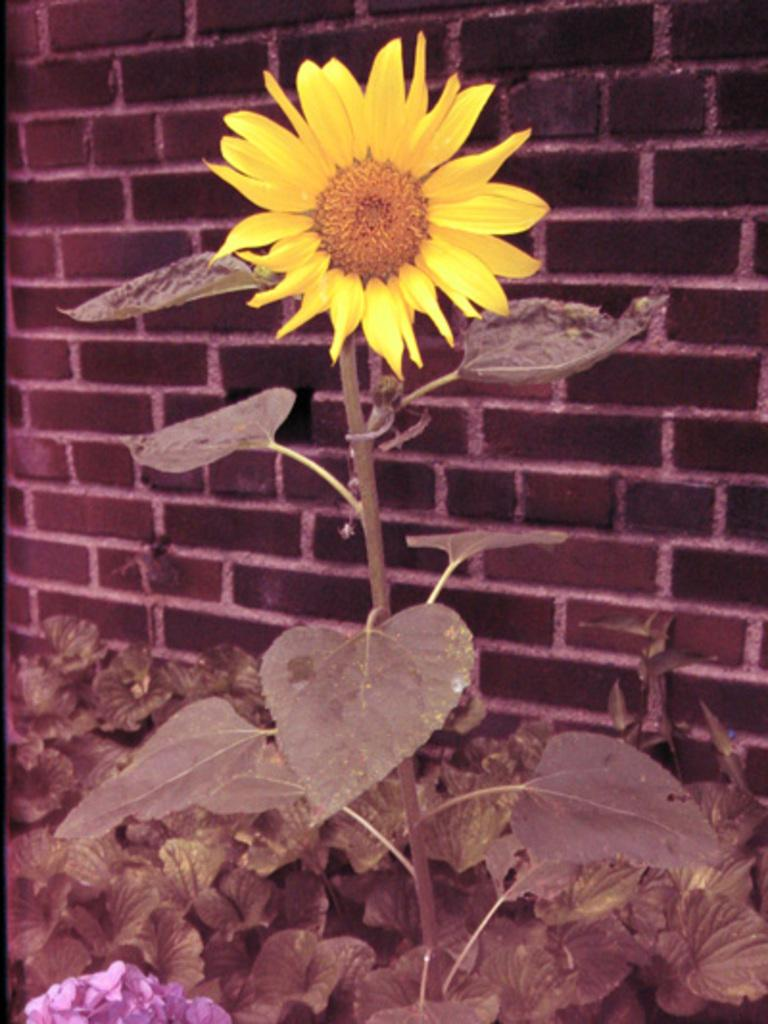What type of flower is on the plant in the image? There is a yellow flower on a plant in the image. Are there any other flowers or plants visible in the image? Yes, there are other plants in the image. What can be seen in the background of the image? There is a brick wall in the background of the image. How do the hands of the flower help it grow in the image? There are no hands present in the image, as flowers do not have hands. The growth of the flower is facilitated by its connection to the plant and the nutrients it receives from the soil and sunlight. 